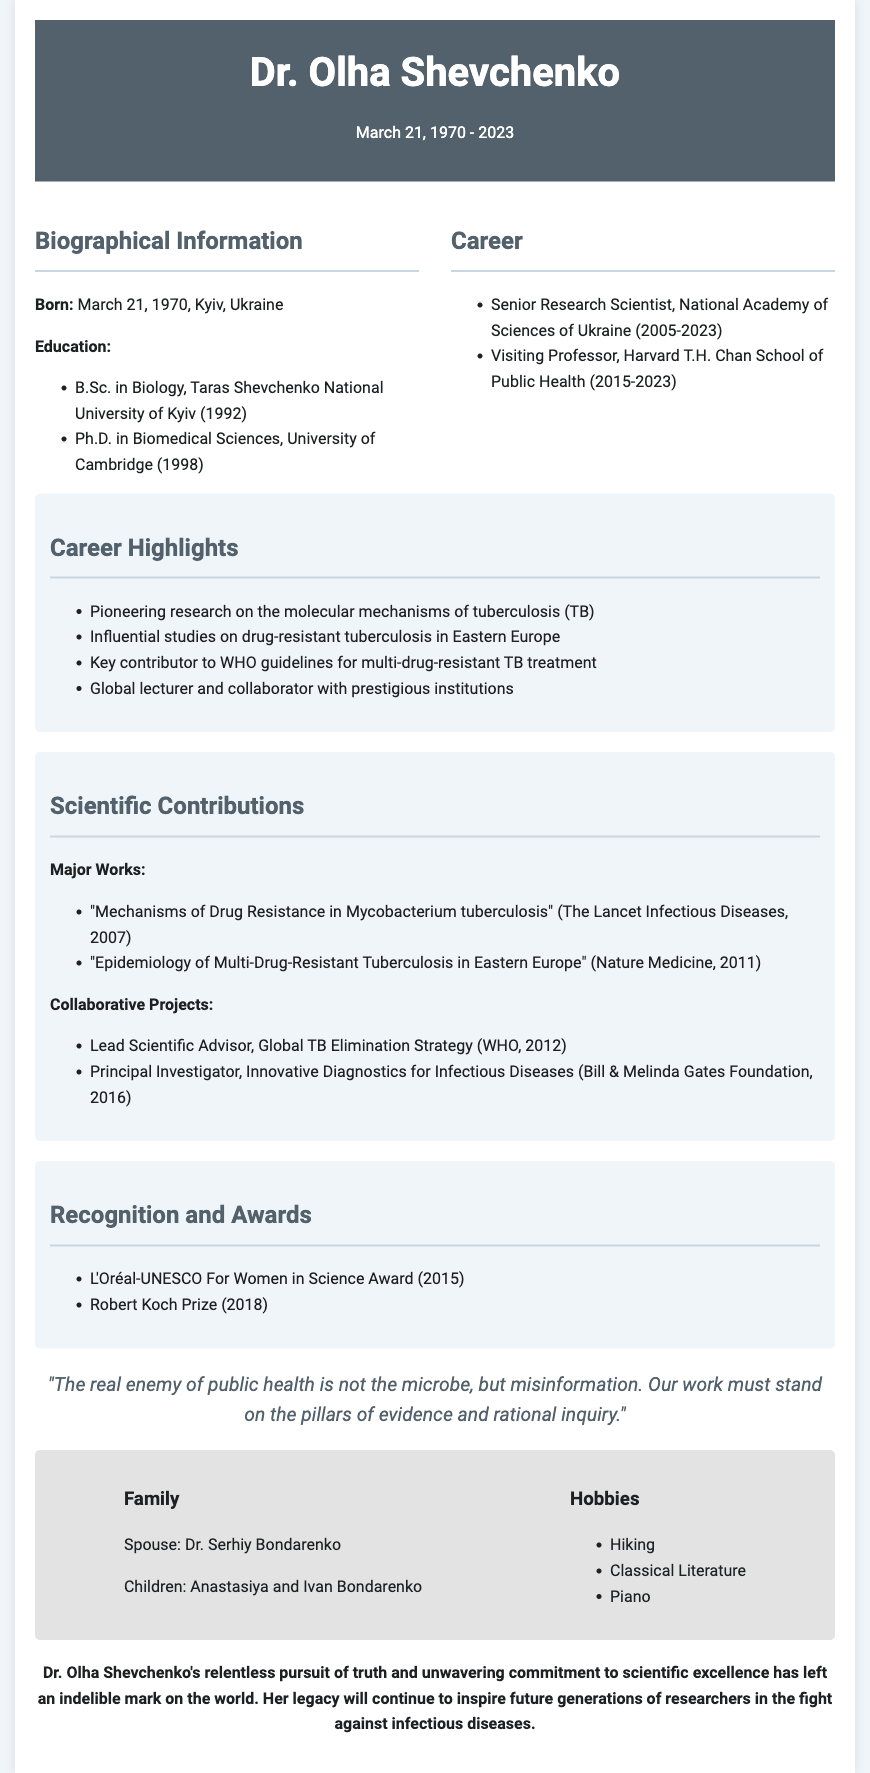What was Dr. Olha Shevchenko's date of birth? The document states her birth date as March 21, 1970.
Answer: March 21, 1970 What was Dr. Shevchenko's highest degree? The document mentions she earned a Ph.D. in Biomedical Sciences.
Answer: Ph.D. in Biomedical Sciences In which year did Dr. Shevchenko receive the L'Oréal-UNESCO For Women in Science Award? The document lists the year of this award as 2015.
Answer: 2015 Which disease was a focal point of Dr. Shevchenko's research? The career highlights section specifically lists tuberculosis (TB).
Answer: Tuberculosis What was the name of Dr. Shevchenko's spouse? The personal life section provides the name as Dr. Serhiy Bondarenko.
Answer: Dr. Serhiy Bondarenko What was the key message in Dr. Shevchenko's quoted statement? The quote emphasizes the importance of evidence and rational inquiry in public health.
Answer: Misinformation How many children did Dr. Shevchenko have? The personal life section states she had two children.
Answer: Two Name one prestigious institution where Dr. Shevchenko was a visiting professor. The document mentions her position at Harvard T.H. Chan School of Public Health.
Answer: Harvard T.H. Chan School of Public Health What is a major contribution made by Dr. Shevchenko listed in the document? The document highlights her work on multi-drug-resistant tuberculosis treatment guidelines for WHO.
Answer: WHO guidelines for multi-drug-resistant TB treatment 